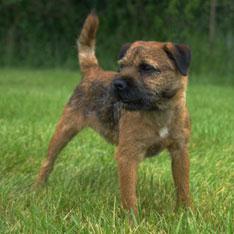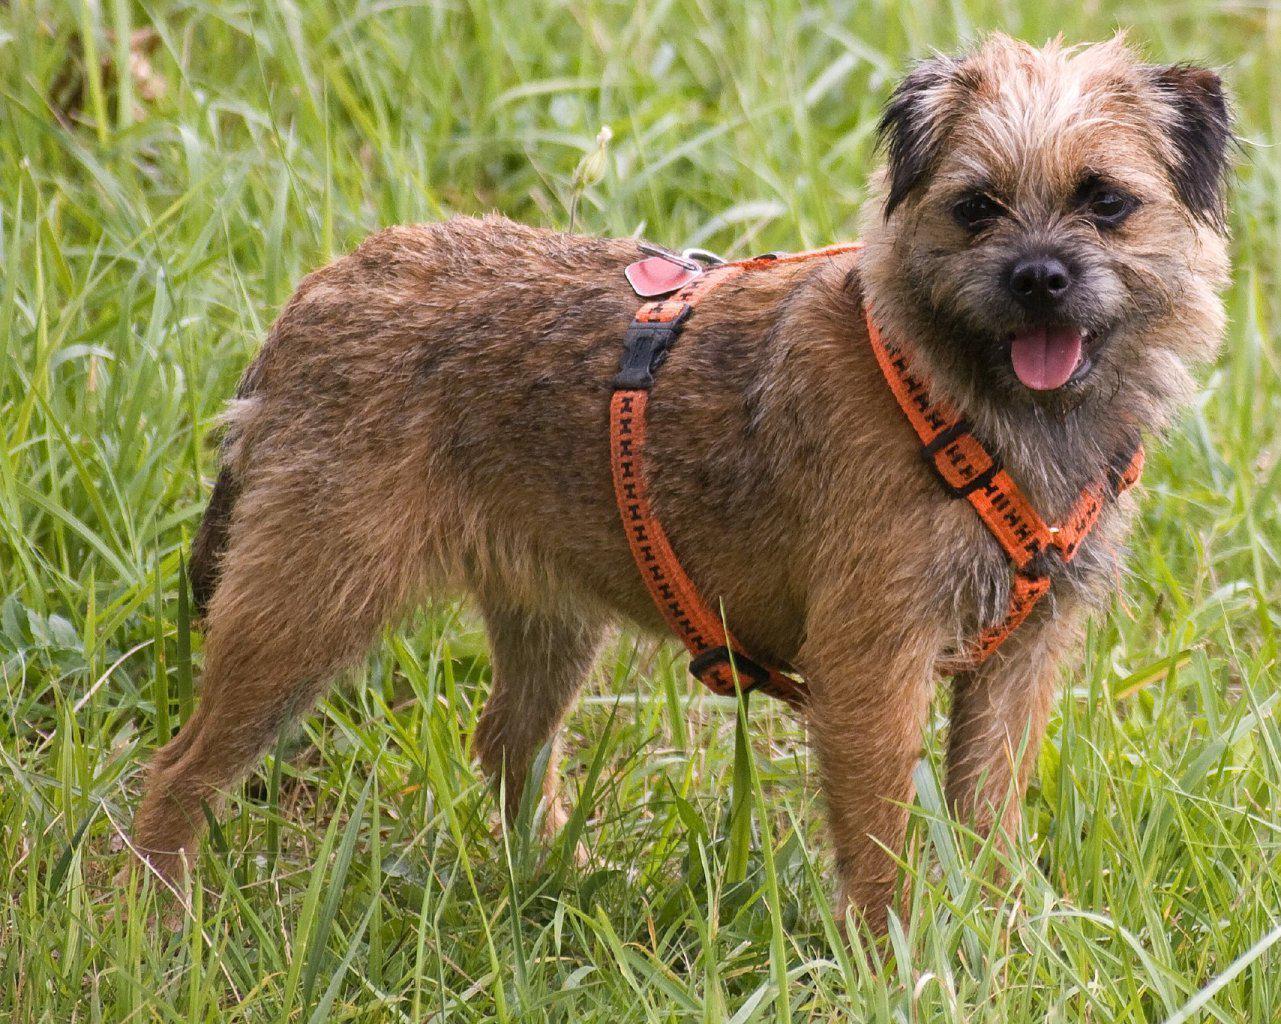The first image is the image on the left, the second image is the image on the right. Analyze the images presented: Is the assertion "One dog is wearing a harness." valid? Answer yes or no. Yes. The first image is the image on the left, the second image is the image on the right. Examine the images to the left and right. Is the description "A dog is shown in profile standing on green grass in at least one image." accurate? Answer yes or no. Yes. 